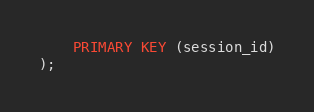Convert code to text. <code><loc_0><loc_0><loc_500><loc_500><_SQL_>    PRIMARY KEY (session_id)
);
</code> 